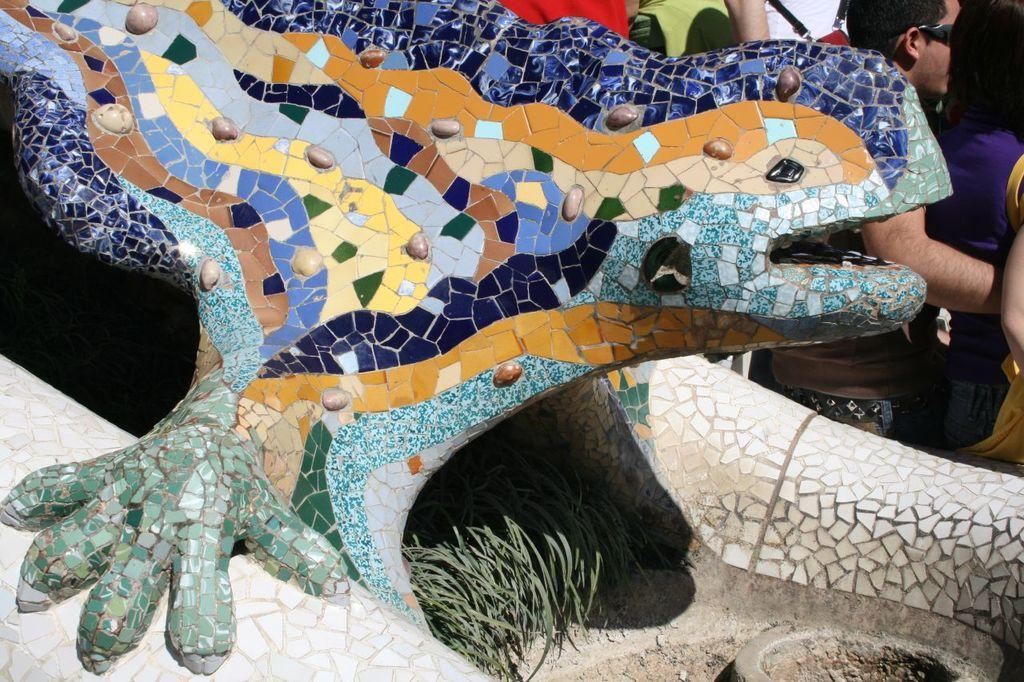What is the main subject of the image? There is a sculpture in the image. What does the sculpture resemble? The sculpture resembles an animal. How are the colors of the sculpture represented? The sculpture has multiple color marbles. Where are the people located in the image? The people are standing on the right top of the image. Can you tell me what letter the animal in the sculpture is trying to spell? There is no indication in the image that the animal in the sculpture is trying to spell any letter. 